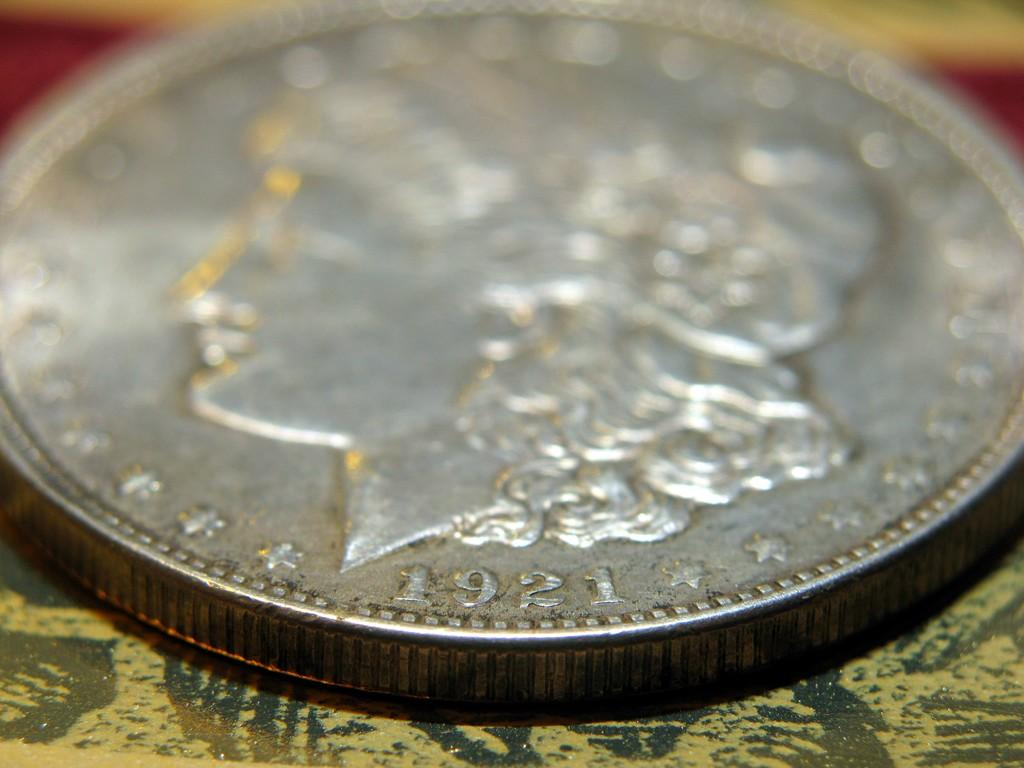What is the main object in the image? There is a currency coin in the image. Can you describe the quality of the image? The top part of the image is slightly blurred. What type of patch can be seen on the foot in the image? There is no foot or patch present in the image; it only features a currency coin. 